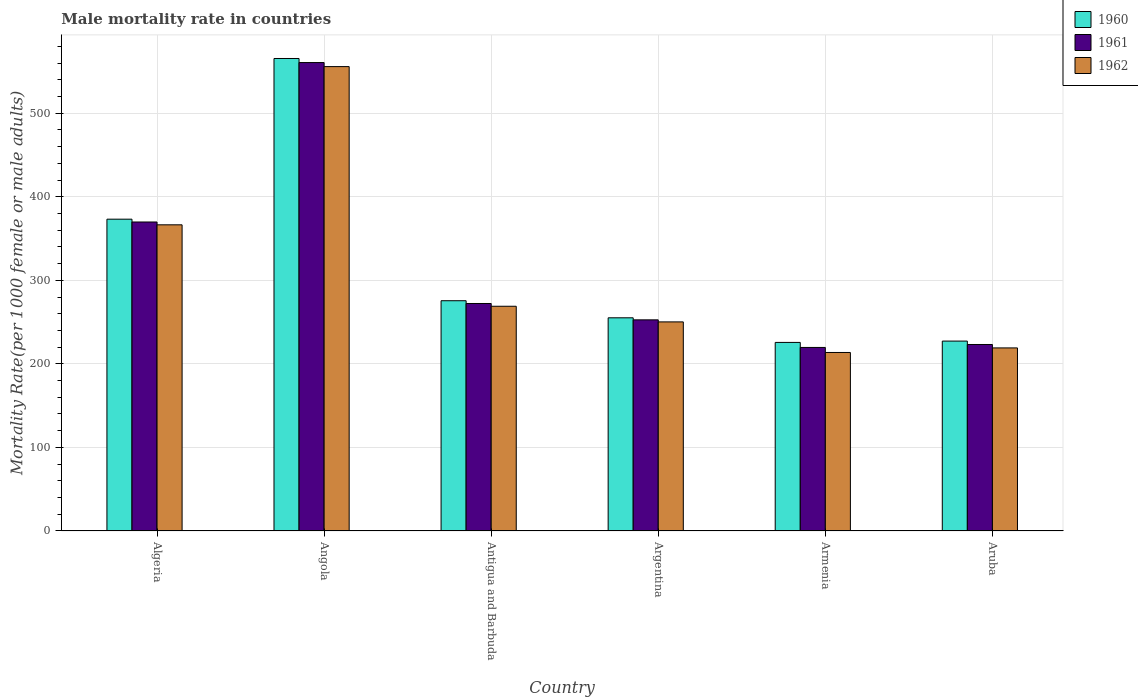How many bars are there on the 4th tick from the right?
Your answer should be compact. 3. What is the label of the 3rd group of bars from the left?
Offer a very short reply. Antigua and Barbuda. What is the male mortality rate in 1961 in Armenia?
Offer a terse response. 219.65. Across all countries, what is the maximum male mortality rate in 1960?
Provide a succinct answer. 565.41. Across all countries, what is the minimum male mortality rate in 1961?
Offer a terse response. 219.65. In which country was the male mortality rate in 1961 maximum?
Offer a terse response. Angola. In which country was the male mortality rate in 1962 minimum?
Offer a terse response. Armenia. What is the total male mortality rate in 1962 in the graph?
Give a very brief answer. 1873.97. What is the difference between the male mortality rate in 1962 in Antigua and Barbuda and that in Argentina?
Give a very brief answer. 18.72. What is the difference between the male mortality rate in 1960 in Aruba and the male mortality rate in 1962 in Angola?
Provide a succinct answer. -328.46. What is the average male mortality rate in 1961 per country?
Your answer should be compact. 316.34. What is the difference between the male mortality rate of/in 1961 and male mortality rate of/in 1960 in Aruba?
Provide a succinct answer. -4.08. In how many countries, is the male mortality rate in 1960 greater than 220?
Keep it short and to the point. 6. What is the ratio of the male mortality rate in 1960 in Algeria to that in Aruba?
Your answer should be compact. 1.64. Is the difference between the male mortality rate in 1961 in Angola and Antigua and Barbuda greater than the difference between the male mortality rate in 1960 in Angola and Antigua and Barbuda?
Your response must be concise. No. What is the difference between the highest and the second highest male mortality rate in 1960?
Your answer should be compact. 97.58. What is the difference between the highest and the lowest male mortality rate in 1960?
Ensure brevity in your answer.  339.74. What does the 3rd bar from the right in Aruba represents?
Give a very brief answer. 1960. Is it the case that in every country, the sum of the male mortality rate in 1961 and male mortality rate in 1962 is greater than the male mortality rate in 1960?
Offer a terse response. Yes. How many bars are there?
Provide a succinct answer. 18. Are all the bars in the graph horizontal?
Your response must be concise. No. What is the difference between two consecutive major ticks on the Y-axis?
Your response must be concise. 100. Are the values on the major ticks of Y-axis written in scientific E-notation?
Provide a succinct answer. No. Does the graph contain grids?
Keep it short and to the point. Yes. Where does the legend appear in the graph?
Give a very brief answer. Top right. What is the title of the graph?
Keep it short and to the point. Male mortality rate in countries. Does "1992" appear as one of the legend labels in the graph?
Make the answer very short. No. What is the label or title of the X-axis?
Offer a very short reply. Country. What is the label or title of the Y-axis?
Offer a terse response. Mortality Rate(per 1000 female or male adults). What is the Mortality Rate(per 1000 female or male adults) of 1960 in Algeria?
Ensure brevity in your answer.  373.13. What is the Mortality Rate(per 1000 female or male adults) in 1961 in Algeria?
Offer a terse response. 369.76. What is the Mortality Rate(per 1000 female or male adults) of 1962 in Algeria?
Your answer should be very brief. 366.39. What is the Mortality Rate(per 1000 female or male adults) in 1960 in Angola?
Your answer should be very brief. 565.41. What is the Mortality Rate(per 1000 female or male adults) in 1961 in Angola?
Offer a very short reply. 560.56. What is the Mortality Rate(per 1000 female or male adults) of 1962 in Angola?
Make the answer very short. 555.71. What is the Mortality Rate(per 1000 female or male adults) of 1960 in Antigua and Barbuda?
Offer a terse response. 275.55. What is the Mortality Rate(per 1000 female or male adults) of 1961 in Antigua and Barbuda?
Offer a very short reply. 272.25. What is the Mortality Rate(per 1000 female or male adults) in 1962 in Antigua and Barbuda?
Make the answer very short. 268.94. What is the Mortality Rate(per 1000 female or male adults) of 1960 in Argentina?
Provide a short and direct response. 255.11. What is the Mortality Rate(per 1000 female or male adults) of 1961 in Argentina?
Your response must be concise. 252.66. What is the Mortality Rate(per 1000 female or male adults) of 1962 in Argentina?
Your answer should be very brief. 250.22. What is the Mortality Rate(per 1000 female or male adults) of 1960 in Armenia?
Ensure brevity in your answer.  225.67. What is the Mortality Rate(per 1000 female or male adults) in 1961 in Armenia?
Your response must be concise. 219.65. What is the Mortality Rate(per 1000 female or male adults) of 1962 in Armenia?
Your answer should be very brief. 213.63. What is the Mortality Rate(per 1000 female or male adults) of 1960 in Aruba?
Keep it short and to the point. 227.25. What is the Mortality Rate(per 1000 female or male adults) of 1961 in Aruba?
Offer a terse response. 223.17. What is the Mortality Rate(per 1000 female or male adults) of 1962 in Aruba?
Keep it short and to the point. 219.09. Across all countries, what is the maximum Mortality Rate(per 1000 female or male adults) in 1960?
Provide a succinct answer. 565.41. Across all countries, what is the maximum Mortality Rate(per 1000 female or male adults) in 1961?
Give a very brief answer. 560.56. Across all countries, what is the maximum Mortality Rate(per 1000 female or male adults) of 1962?
Keep it short and to the point. 555.71. Across all countries, what is the minimum Mortality Rate(per 1000 female or male adults) in 1960?
Provide a succinct answer. 225.67. Across all countries, what is the minimum Mortality Rate(per 1000 female or male adults) in 1961?
Keep it short and to the point. 219.65. Across all countries, what is the minimum Mortality Rate(per 1000 female or male adults) in 1962?
Offer a very short reply. 213.63. What is the total Mortality Rate(per 1000 female or male adults) in 1960 in the graph?
Your response must be concise. 1922.13. What is the total Mortality Rate(per 1000 female or male adults) in 1961 in the graph?
Offer a very short reply. 1898.05. What is the total Mortality Rate(per 1000 female or male adults) of 1962 in the graph?
Give a very brief answer. 1873.96. What is the difference between the Mortality Rate(per 1000 female or male adults) in 1960 in Algeria and that in Angola?
Make the answer very short. -192.28. What is the difference between the Mortality Rate(per 1000 female or male adults) in 1961 in Algeria and that in Angola?
Offer a very short reply. -190.8. What is the difference between the Mortality Rate(per 1000 female or male adults) of 1962 in Algeria and that in Angola?
Offer a very short reply. -189.32. What is the difference between the Mortality Rate(per 1000 female or male adults) of 1960 in Algeria and that in Antigua and Barbuda?
Provide a short and direct response. 97.58. What is the difference between the Mortality Rate(per 1000 female or male adults) of 1961 in Algeria and that in Antigua and Barbuda?
Ensure brevity in your answer.  97.51. What is the difference between the Mortality Rate(per 1000 female or male adults) of 1962 in Algeria and that in Antigua and Barbuda?
Keep it short and to the point. 97.45. What is the difference between the Mortality Rate(per 1000 female or male adults) in 1960 in Algeria and that in Argentina?
Provide a succinct answer. 118.02. What is the difference between the Mortality Rate(per 1000 female or male adults) of 1961 in Algeria and that in Argentina?
Ensure brevity in your answer.  117.1. What is the difference between the Mortality Rate(per 1000 female or male adults) of 1962 in Algeria and that in Argentina?
Your answer should be compact. 116.17. What is the difference between the Mortality Rate(per 1000 female or male adults) in 1960 in Algeria and that in Armenia?
Give a very brief answer. 147.46. What is the difference between the Mortality Rate(per 1000 female or male adults) of 1961 in Algeria and that in Armenia?
Offer a terse response. 150.11. What is the difference between the Mortality Rate(per 1000 female or male adults) of 1962 in Algeria and that in Armenia?
Ensure brevity in your answer.  152.76. What is the difference between the Mortality Rate(per 1000 female or male adults) in 1960 in Algeria and that in Aruba?
Your response must be concise. 145.88. What is the difference between the Mortality Rate(per 1000 female or male adults) in 1961 in Algeria and that in Aruba?
Make the answer very short. 146.59. What is the difference between the Mortality Rate(per 1000 female or male adults) in 1962 in Algeria and that in Aruba?
Make the answer very short. 147.3. What is the difference between the Mortality Rate(per 1000 female or male adults) of 1960 in Angola and that in Antigua and Barbuda?
Your response must be concise. 289.86. What is the difference between the Mortality Rate(per 1000 female or male adults) of 1961 in Angola and that in Antigua and Barbuda?
Your answer should be compact. 288.31. What is the difference between the Mortality Rate(per 1000 female or male adults) in 1962 in Angola and that in Antigua and Barbuda?
Your answer should be compact. 286.77. What is the difference between the Mortality Rate(per 1000 female or male adults) of 1960 in Angola and that in Argentina?
Offer a very short reply. 310.3. What is the difference between the Mortality Rate(per 1000 female or male adults) in 1961 in Angola and that in Argentina?
Give a very brief answer. 307.9. What is the difference between the Mortality Rate(per 1000 female or male adults) of 1962 in Angola and that in Argentina?
Provide a short and direct response. 305.49. What is the difference between the Mortality Rate(per 1000 female or male adults) of 1960 in Angola and that in Armenia?
Offer a very short reply. 339.74. What is the difference between the Mortality Rate(per 1000 female or male adults) in 1961 in Angola and that in Armenia?
Give a very brief answer. 340.91. What is the difference between the Mortality Rate(per 1000 female or male adults) in 1962 in Angola and that in Armenia?
Offer a very short reply. 342.08. What is the difference between the Mortality Rate(per 1000 female or male adults) in 1960 in Angola and that in Aruba?
Your answer should be compact. 338.16. What is the difference between the Mortality Rate(per 1000 female or male adults) of 1961 in Angola and that in Aruba?
Provide a succinct answer. 337.39. What is the difference between the Mortality Rate(per 1000 female or male adults) in 1962 in Angola and that in Aruba?
Provide a short and direct response. 336.62. What is the difference between the Mortality Rate(per 1000 female or male adults) of 1960 in Antigua and Barbuda and that in Argentina?
Provide a succinct answer. 20.44. What is the difference between the Mortality Rate(per 1000 female or male adults) in 1961 in Antigua and Barbuda and that in Argentina?
Offer a very short reply. 19.58. What is the difference between the Mortality Rate(per 1000 female or male adults) in 1962 in Antigua and Barbuda and that in Argentina?
Your response must be concise. 18.72. What is the difference between the Mortality Rate(per 1000 female or male adults) in 1960 in Antigua and Barbuda and that in Armenia?
Provide a short and direct response. 49.88. What is the difference between the Mortality Rate(per 1000 female or male adults) in 1961 in Antigua and Barbuda and that in Armenia?
Make the answer very short. 52.6. What is the difference between the Mortality Rate(per 1000 female or male adults) in 1962 in Antigua and Barbuda and that in Armenia?
Make the answer very short. 55.31. What is the difference between the Mortality Rate(per 1000 female or male adults) in 1960 in Antigua and Barbuda and that in Aruba?
Provide a succinct answer. 48.3. What is the difference between the Mortality Rate(per 1000 female or male adults) of 1961 in Antigua and Barbuda and that in Aruba?
Your answer should be very brief. 49.08. What is the difference between the Mortality Rate(per 1000 female or male adults) of 1962 in Antigua and Barbuda and that in Aruba?
Keep it short and to the point. 49.85. What is the difference between the Mortality Rate(per 1000 female or male adults) of 1960 in Argentina and that in Armenia?
Your answer should be very brief. 29.44. What is the difference between the Mortality Rate(per 1000 female or male adults) of 1961 in Argentina and that in Armenia?
Offer a terse response. 33.02. What is the difference between the Mortality Rate(per 1000 female or male adults) in 1962 in Argentina and that in Armenia?
Provide a succinct answer. 36.59. What is the difference between the Mortality Rate(per 1000 female or male adults) in 1960 in Argentina and that in Aruba?
Ensure brevity in your answer.  27.86. What is the difference between the Mortality Rate(per 1000 female or male adults) of 1961 in Argentina and that in Aruba?
Give a very brief answer. 29.49. What is the difference between the Mortality Rate(per 1000 female or male adults) in 1962 in Argentina and that in Aruba?
Make the answer very short. 31.13. What is the difference between the Mortality Rate(per 1000 female or male adults) in 1960 in Armenia and that in Aruba?
Offer a very short reply. -1.58. What is the difference between the Mortality Rate(per 1000 female or male adults) in 1961 in Armenia and that in Aruba?
Offer a very short reply. -3.52. What is the difference between the Mortality Rate(per 1000 female or male adults) in 1962 in Armenia and that in Aruba?
Your response must be concise. -5.46. What is the difference between the Mortality Rate(per 1000 female or male adults) of 1960 in Algeria and the Mortality Rate(per 1000 female or male adults) of 1961 in Angola?
Provide a succinct answer. -187.43. What is the difference between the Mortality Rate(per 1000 female or male adults) in 1960 in Algeria and the Mortality Rate(per 1000 female or male adults) in 1962 in Angola?
Make the answer very short. -182.58. What is the difference between the Mortality Rate(per 1000 female or male adults) in 1961 in Algeria and the Mortality Rate(per 1000 female or male adults) in 1962 in Angola?
Offer a very short reply. -185.95. What is the difference between the Mortality Rate(per 1000 female or male adults) of 1960 in Algeria and the Mortality Rate(per 1000 female or male adults) of 1961 in Antigua and Barbuda?
Provide a short and direct response. 100.89. What is the difference between the Mortality Rate(per 1000 female or male adults) of 1960 in Algeria and the Mortality Rate(per 1000 female or male adults) of 1962 in Antigua and Barbuda?
Ensure brevity in your answer.  104.19. What is the difference between the Mortality Rate(per 1000 female or male adults) in 1961 in Algeria and the Mortality Rate(per 1000 female or male adults) in 1962 in Antigua and Barbuda?
Your answer should be very brief. 100.82. What is the difference between the Mortality Rate(per 1000 female or male adults) in 1960 in Algeria and the Mortality Rate(per 1000 female or male adults) in 1961 in Argentina?
Give a very brief answer. 120.47. What is the difference between the Mortality Rate(per 1000 female or male adults) of 1960 in Algeria and the Mortality Rate(per 1000 female or male adults) of 1962 in Argentina?
Make the answer very short. 122.91. What is the difference between the Mortality Rate(per 1000 female or male adults) of 1961 in Algeria and the Mortality Rate(per 1000 female or male adults) of 1962 in Argentina?
Your answer should be very brief. 119.54. What is the difference between the Mortality Rate(per 1000 female or male adults) in 1960 in Algeria and the Mortality Rate(per 1000 female or male adults) in 1961 in Armenia?
Your response must be concise. 153.48. What is the difference between the Mortality Rate(per 1000 female or male adults) in 1960 in Algeria and the Mortality Rate(per 1000 female or male adults) in 1962 in Armenia?
Keep it short and to the point. 159.51. What is the difference between the Mortality Rate(per 1000 female or male adults) of 1961 in Algeria and the Mortality Rate(per 1000 female or male adults) of 1962 in Armenia?
Offer a terse response. 156.13. What is the difference between the Mortality Rate(per 1000 female or male adults) in 1960 in Algeria and the Mortality Rate(per 1000 female or male adults) in 1961 in Aruba?
Ensure brevity in your answer.  149.96. What is the difference between the Mortality Rate(per 1000 female or male adults) of 1960 in Algeria and the Mortality Rate(per 1000 female or male adults) of 1962 in Aruba?
Keep it short and to the point. 154.04. What is the difference between the Mortality Rate(per 1000 female or male adults) of 1961 in Algeria and the Mortality Rate(per 1000 female or male adults) of 1962 in Aruba?
Your answer should be very brief. 150.67. What is the difference between the Mortality Rate(per 1000 female or male adults) in 1960 in Angola and the Mortality Rate(per 1000 female or male adults) in 1961 in Antigua and Barbuda?
Offer a very short reply. 293.17. What is the difference between the Mortality Rate(per 1000 female or male adults) in 1960 in Angola and the Mortality Rate(per 1000 female or male adults) in 1962 in Antigua and Barbuda?
Offer a terse response. 296.47. What is the difference between the Mortality Rate(per 1000 female or male adults) of 1961 in Angola and the Mortality Rate(per 1000 female or male adults) of 1962 in Antigua and Barbuda?
Your answer should be very brief. 291.62. What is the difference between the Mortality Rate(per 1000 female or male adults) in 1960 in Angola and the Mortality Rate(per 1000 female or male adults) in 1961 in Argentina?
Give a very brief answer. 312.75. What is the difference between the Mortality Rate(per 1000 female or male adults) in 1960 in Angola and the Mortality Rate(per 1000 female or male adults) in 1962 in Argentina?
Give a very brief answer. 315.19. What is the difference between the Mortality Rate(per 1000 female or male adults) of 1961 in Angola and the Mortality Rate(per 1000 female or male adults) of 1962 in Argentina?
Ensure brevity in your answer.  310.34. What is the difference between the Mortality Rate(per 1000 female or male adults) in 1960 in Angola and the Mortality Rate(per 1000 female or male adults) in 1961 in Armenia?
Give a very brief answer. 345.76. What is the difference between the Mortality Rate(per 1000 female or male adults) of 1960 in Angola and the Mortality Rate(per 1000 female or male adults) of 1962 in Armenia?
Offer a very short reply. 351.78. What is the difference between the Mortality Rate(per 1000 female or male adults) of 1961 in Angola and the Mortality Rate(per 1000 female or male adults) of 1962 in Armenia?
Make the answer very short. 346.93. What is the difference between the Mortality Rate(per 1000 female or male adults) of 1960 in Angola and the Mortality Rate(per 1000 female or male adults) of 1961 in Aruba?
Keep it short and to the point. 342.24. What is the difference between the Mortality Rate(per 1000 female or male adults) in 1960 in Angola and the Mortality Rate(per 1000 female or male adults) in 1962 in Aruba?
Your answer should be very brief. 346.32. What is the difference between the Mortality Rate(per 1000 female or male adults) in 1961 in Angola and the Mortality Rate(per 1000 female or male adults) in 1962 in Aruba?
Provide a succinct answer. 341.47. What is the difference between the Mortality Rate(per 1000 female or male adults) of 1960 in Antigua and Barbuda and the Mortality Rate(per 1000 female or male adults) of 1961 in Argentina?
Your answer should be very brief. 22.89. What is the difference between the Mortality Rate(per 1000 female or male adults) in 1960 in Antigua and Barbuda and the Mortality Rate(per 1000 female or male adults) in 1962 in Argentina?
Provide a short and direct response. 25.33. What is the difference between the Mortality Rate(per 1000 female or male adults) in 1961 in Antigua and Barbuda and the Mortality Rate(per 1000 female or male adults) in 1962 in Argentina?
Offer a very short reply. 22.03. What is the difference between the Mortality Rate(per 1000 female or male adults) of 1960 in Antigua and Barbuda and the Mortality Rate(per 1000 female or male adults) of 1961 in Armenia?
Your answer should be very brief. 55.9. What is the difference between the Mortality Rate(per 1000 female or male adults) of 1960 in Antigua and Barbuda and the Mortality Rate(per 1000 female or male adults) of 1962 in Armenia?
Offer a terse response. 61.93. What is the difference between the Mortality Rate(per 1000 female or male adults) in 1961 in Antigua and Barbuda and the Mortality Rate(per 1000 female or male adults) in 1962 in Armenia?
Ensure brevity in your answer.  58.62. What is the difference between the Mortality Rate(per 1000 female or male adults) in 1960 in Antigua and Barbuda and the Mortality Rate(per 1000 female or male adults) in 1961 in Aruba?
Offer a terse response. 52.38. What is the difference between the Mortality Rate(per 1000 female or male adults) in 1960 in Antigua and Barbuda and the Mortality Rate(per 1000 female or male adults) in 1962 in Aruba?
Keep it short and to the point. 56.47. What is the difference between the Mortality Rate(per 1000 female or male adults) in 1961 in Antigua and Barbuda and the Mortality Rate(per 1000 female or male adults) in 1962 in Aruba?
Give a very brief answer. 53.16. What is the difference between the Mortality Rate(per 1000 female or male adults) in 1960 in Argentina and the Mortality Rate(per 1000 female or male adults) in 1961 in Armenia?
Give a very brief answer. 35.46. What is the difference between the Mortality Rate(per 1000 female or male adults) in 1960 in Argentina and the Mortality Rate(per 1000 female or male adults) in 1962 in Armenia?
Offer a terse response. 41.48. What is the difference between the Mortality Rate(per 1000 female or male adults) of 1961 in Argentina and the Mortality Rate(per 1000 female or male adults) of 1962 in Armenia?
Your answer should be compact. 39.04. What is the difference between the Mortality Rate(per 1000 female or male adults) in 1960 in Argentina and the Mortality Rate(per 1000 female or male adults) in 1961 in Aruba?
Ensure brevity in your answer.  31.94. What is the difference between the Mortality Rate(per 1000 female or male adults) in 1960 in Argentina and the Mortality Rate(per 1000 female or male adults) in 1962 in Aruba?
Provide a short and direct response. 36.02. What is the difference between the Mortality Rate(per 1000 female or male adults) in 1961 in Argentina and the Mortality Rate(per 1000 female or male adults) in 1962 in Aruba?
Ensure brevity in your answer.  33.58. What is the difference between the Mortality Rate(per 1000 female or male adults) in 1960 in Armenia and the Mortality Rate(per 1000 female or male adults) in 1961 in Aruba?
Provide a short and direct response. 2.5. What is the difference between the Mortality Rate(per 1000 female or male adults) in 1960 in Armenia and the Mortality Rate(per 1000 female or male adults) in 1962 in Aruba?
Ensure brevity in your answer.  6.58. What is the difference between the Mortality Rate(per 1000 female or male adults) in 1961 in Armenia and the Mortality Rate(per 1000 female or male adults) in 1962 in Aruba?
Offer a terse response. 0.56. What is the average Mortality Rate(per 1000 female or male adults) of 1960 per country?
Offer a terse response. 320.35. What is the average Mortality Rate(per 1000 female or male adults) in 1961 per country?
Your answer should be compact. 316.34. What is the average Mortality Rate(per 1000 female or male adults) in 1962 per country?
Your answer should be compact. 312.33. What is the difference between the Mortality Rate(per 1000 female or male adults) in 1960 and Mortality Rate(per 1000 female or male adults) in 1961 in Algeria?
Provide a short and direct response. 3.37. What is the difference between the Mortality Rate(per 1000 female or male adults) of 1960 and Mortality Rate(per 1000 female or male adults) of 1962 in Algeria?
Give a very brief answer. 6.75. What is the difference between the Mortality Rate(per 1000 female or male adults) in 1961 and Mortality Rate(per 1000 female or male adults) in 1962 in Algeria?
Your response must be concise. 3.37. What is the difference between the Mortality Rate(per 1000 female or male adults) of 1960 and Mortality Rate(per 1000 female or male adults) of 1961 in Angola?
Keep it short and to the point. 4.85. What is the difference between the Mortality Rate(per 1000 female or male adults) of 1960 and Mortality Rate(per 1000 female or male adults) of 1962 in Angola?
Provide a short and direct response. 9.7. What is the difference between the Mortality Rate(per 1000 female or male adults) of 1961 and Mortality Rate(per 1000 female or male adults) of 1962 in Angola?
Offer a very short reply. 4.85. What is the difference between the Mortality Rate(per 1000 female or male adults) in 1960 and Mortality Rate(per 1000 female or male adults) in 1961 in Antigua and Barbuda?
Provide a short and direct response. 3.31. What is the difference between the Mortality Rate(per 1000 female or male adults) in 1960 and Mortality Rate(per 1000 female or male adults) in 1962 in Antigua and Barbuda?
Ensure brevity in your answer.  6.61. What is the difference between the Mortality Rate(per 1000 female or male adults) of 1961 and Mortality Rate(per 1000 female or male adults) of 1962 in Antigua and Barbuda?
Provide a succinct answer. 3.31. What is the difference between the Mortality Rate(per 1000 female or male adults) in 1960 and Mortality Rate(per 1000 female or male adults) in 1961 in Argentina?
Offer a terse response. 2.44. What is the difference between the Mortality Rate(per 1000 female or male adults) in 1960 and Mortality Rate(per 1000 female or male adults) in 1962 in Argentina?
Offer a terse response. 4.89. What is the difference between the Mortality Rate(per 1000 female or male adults) in 1961 and Mortality Rate(per 1000 female or male adults) in 1962 in Argentina?
Offer a terse response. 2.44. What is the difference between the Mortality Rate(per 1000 female or male adults) of 1960 and Mortality Rate(per 1000 female or male adults) of 1961 in Armenia?
Your answer should be compact. 6.02. What is the difference between the Mortality Rate(per 1000 female or male adults) in 1960 and Mortality Rate(per 1000 female or male adults) in 1962 in Armenia?
Your response must be concise. 12.04. What is the difference between the Mortality Rate(per 1000 female or male adults) of 1961 and Mortality Rate(per 1000 female or male adults) of 1962 in Armenia?
Offer a terse response. 6.02. What is the difference between the Mortality Rate(per 1000 female or male adults) in 1960 and Mortality Rate(per 1000 female or male adults) in 1961 in Aruba?
Offer a terse response. 4.08. What is the difference between the Mortality Rate(per 1000 female or male adults) in 1960 and Mortality Rate(per 1000 female or male adults) in 1962 in Aruba?
Make the answer very short. 8.17. What is the difference between the Mortality Rate(per 1000 female or male adults) in 1961 and Mortality Rate(per 1000 female or male adults) in 1962 in Aruba?
Ensure brevity in your answer.  4.08. What is the ratio of the Mortality Rate(per 1000 female or male adults) in 1960 in Algeria to that in Angola?
Ensure brevity in your answer.  0.66. What is the ratio of the Mortality Rate(per 1000 female or male adults) of 1961 in Algeria to that in Angola?
Ensure brevity in your answer.  0.66. What is the ratio of the Mortality Rate(per 1000 female or male adults) of 1962 in Algeria to that in Angola?
Provide a succinct answer. 0.66. What is the ratio of the Mortality Rate(per 1000 female or male adults) of 1960 in Algeria to that in Antigua and Barbuda?
Keep it short and to the point. 1.35. What is the ratio of the Mortality Rate(per 1000 female or male adults) in 1961 in Algeria to that in Antigua and Barbuda?
Your answer should be very brief. 1.36. What is the ratio of the Mortality Rate(per 1000 female or male adults) in 1962 in Algeria to that in Antigua and Barbuda?
Provide a succinct answer. 1.36. What is the ratio of the Mortality Rate(per 1000 female or male adults) in 1960 in Algeria to that in Argentina?
Offer a terse response. 1.46. What is the ratio of the Mortality Rate(per 1000 female or male adults) in 1961 in Algeria to that in Argentina?
Offer a terse response. 1.46. What is the ratio of the Mortality Rate(per 1000 female or male adults) of 1962 in Algeria to that in Argentina?
Make the answer very short. 1.46. What is the ratio of the Mortality Rate(per 1000 female or male adults) in 1960 in Algeria to that in Armenia?
Provide a short and direct response. 1.65. What is the ratio of the Mortality Rate(per 1000 female or male adults) of 1961 in Algeria to that in Armenia?
Your response must be concise. 1.68. What is the ratio of the Mortality Rate(per 1000 female or male adults) in 1962 in Algeria to that in Armenia?
Keep it short and to the point. 1.72. What is the ratio of the Mortality Rate(per 1000 female or male adults) of 1960 in Algeria to that in Aruba?
Your response must be concise. 1.64. What is the ratio of the Mortality Rate(per 1000 female or male adults) in 1961 in Algeria to that in Aruba?
Ensure brevity in your answer.  1.66. What is the ratio of the Mortality Rate(per 1000 female or male adults) in 1962 in Algeria to that in Aruba?
Your answer should be very brief. 1.67. What is the ratio of the Mortality Rate(per 1000 female or male adults) of 1960 in Angola to that in Antigua and Barbuda?
Your response must be concise. 2.05. What is the ratio of the Mortality Rate(per 1000 female or male adults) of 1961 in Angola to that in Antigua and Barbuda?
Give a very brief answer. 2.06. What is the ratio of the Mortality Rate(per 1000 female or male adults) in 1962 in Angola to that in Antigua and Barbuda?
Your answer should be compact. 2.07. What is the ratio of the Mortality Rate(per 1000 female or male adults) of 1960 in Angola to that in Argentina?
Offer a terse response. 2.22. What is the ratio of the Mortality Rate(per 1000 female or male adults) of 1961 in Angola to that in Argentina?
Keep it short and to the point. 2.22. What is the ratio of the Mortality Rate(per 1000 female or male adults) in 1962 in Angola to that in Argentina?
Your answer should be compact. 2.22. What is the ratio of the Mortality Rate(per 1000 female or male adults) of 1960 in Angola to that in Armenia?
Make the answer very short. 2.51. What is the ratio of the Mortality Rate(per 1000 female or male adults) of 1961 in Angola to that in Armenia?
Provide a succinct answer. 2.55. What is the ratio of the Mortality Rate(per 1000 female or male adults) of 1962 in Angola to that in Armenia?
Give a very brief answer. 2.6. What is the ratio of the Mortality Rate(per 1000 female or male adults) of 1960 in Angola to that in Aruba?
Your response must be concise. 2.49. What is the ratio of the Mortality Rate(per 1000 female or male adults) of 1961 in Angola to that in Aruba?
Give a very brief answer. 2.51. What is the ratio of the Mortality Rate(per 1000 female or male adults) in 1962 in Angola to that in Aruba?
Ensure brevity in your answer.  2.54. What is the ratio of the Mortality Rate(per 1000 female or male adults) in 1960 in Antigua and Barbuda to that in Argentina?
Your response must be concise. 1.08. What is the ratio of the Mortality Rate(per 1000 female or male adults) in 1961 in Antigua and Barbuda to that in Argentina?
Your response must be concise. 1.08. What is the ratio of the Mortality Rate(per 1000 female or male adults) of 1962 in Antigua and Barbuda to that in Argentina?
Give a very brief answer. 1.07. What is the ratio of the Mortality Rate(per 1000 female or male adults) of 1960 in Antigua and Barbuda to that in Armenia?
Offer a terse response. 1.22. What is the ratio of the Mortality Rate(per 1000 female or male adults) of 1961 in Antigua and Barbuda to that in Armenia?
Provide a short and direct response. 1.24. What is the ratio of the Mortality Rate(per 1000 female or male adults) of 1962 in Antigua and Barbuda to that in Armenia?
Your response must be concise. 1.26. What is the ratio of the Mortality Rate(per 1000 female or male adults) in 1960 in Antigua and Barbuda to that in Aruba?
Ensure brevity in your answer.  1.21. What is the ratio of the Mortality Rate(per 1000 female or male adults) of 1961 in Antigua and Barbuda to that in Aruba?
Make the answer very short. 1.22. What is the ratio of the Mortality Rate(per 1000 female or male adults) of 1962 in Antigua and Barbuda to that in Aruba?
Make the answer very short. 1.23. What is the ratio of the Mortality Rate(per 1000 female or male adults) of 1960 in Argentina to that in Armenia?
Keep it short and to the point. 1.13. What is the ratio of the Mortality Rate(per 1000 female or male adults) of 1961 in Argentina to that in Armenia?
Make the answer very short. 1.15. What is the ratio of the Mortality Rate(per 1000 female or male adults) in 1962 in Argentina to that in Armenia?
Keep it short and to the point. 1.17. What is the ratio of the Mortality Rate(per 1000 female or male adults) of 1960 in Argentina to that in Aruba?
Offer a very short reply. 1.12. What is the ratio of the Mortality Rate(per 1000 female or male adults) of 1961 in Argentina to that in Aruba?
Offer a very short reply. 1.13. What is the ratio of the Mortality Rate(per 1000 female or male adults) in 1962 in Argentina to that in Aruba?
Ensure brevity in your answer.  1.14. What is the ratio of the Mortality Rate(per 1000 female or male adults) of 1961 in Armenia to that in Aruba?
Offer a very short reply. 0.98. What is the ratio of the Mortality Rate(per 1000 female or male adults) in 1962 in Armenia to that in Aruba?
Offer a terse response. 0.98. What is the difference between the highest and the second highest Mortality Rate(per 1000 female or male adults) in 1960?
Your response must be concise. 192.28. What is the difference between the highest and the second highest Mortality Rate(per 1000 female or male adults) in 1961?
Give a very brief answer. 190.8. What is the difference between the highest and the second highest Mortality Rate(per 1000 female or male adults) of 1962?
Keep it short and to the point. 189.32. What is the difference between the highest and the lowest Mortality Rate(per 1000 female or male adults) of 1960?
Provide a short and direct response. 339.74. What is the difference between the highest and the lowest Mortality Rate(per 1000 female or male adults) in 1961?
Offer a very short reply. 340.91. What is the difference between the highest and the lowest Mortality Rate(per 1000 female or male adults) in 1962?
Your response must be concise. 342.08. 